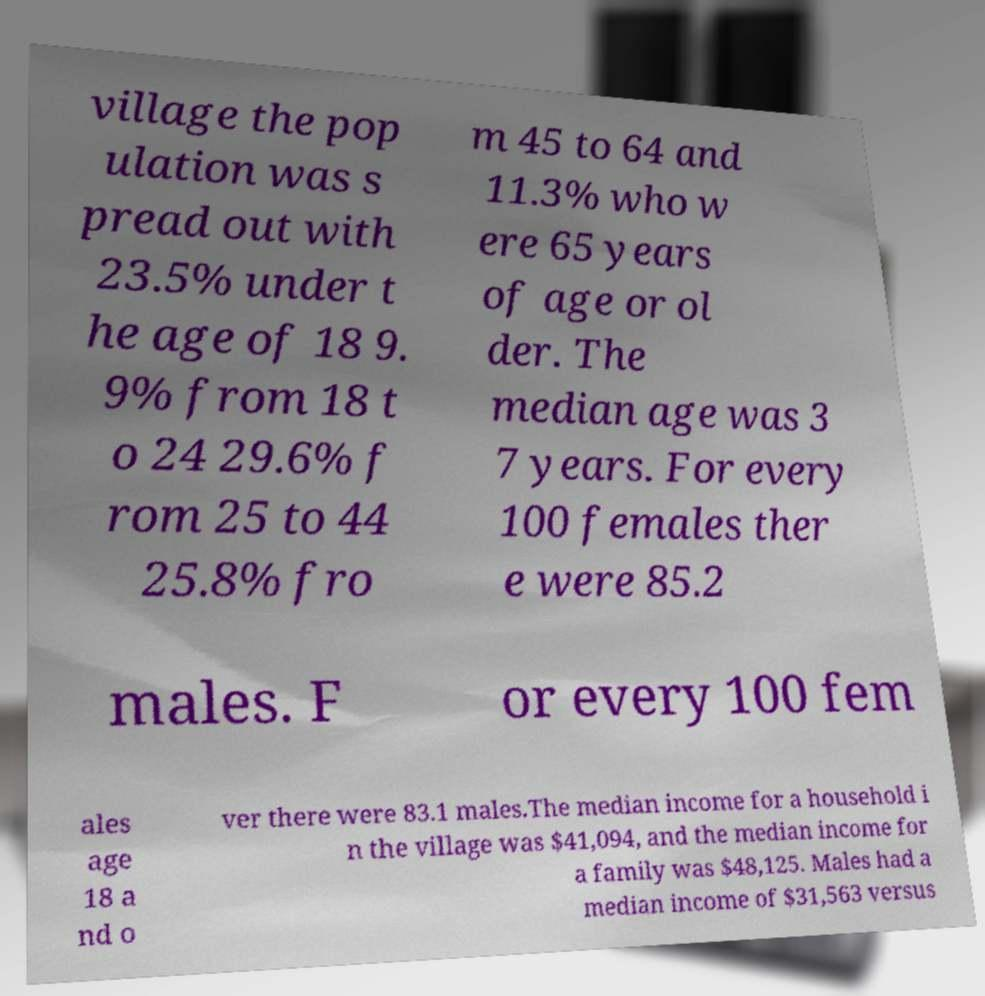There's text embedded in this image that I need extracted. Can you transcribe it verbatim? village the pop ulation was s pread out with 23.5% under t he age of 18 9. 9% from 18 t o 24 29.6% f rom 25 to 44 25.8% fro m 45 to 64 and 11.3% who w ere 65 years of age or ol der. The median age was 3 7 years. For every 100 females ther e were 85.2 males. F or every 100 fem ales age 18 a nd o ver there were 83.1 males.The median income for a household i n the village was $41,094, and the median income for a family was $48,125. Males had a median income of $31,563 versus 